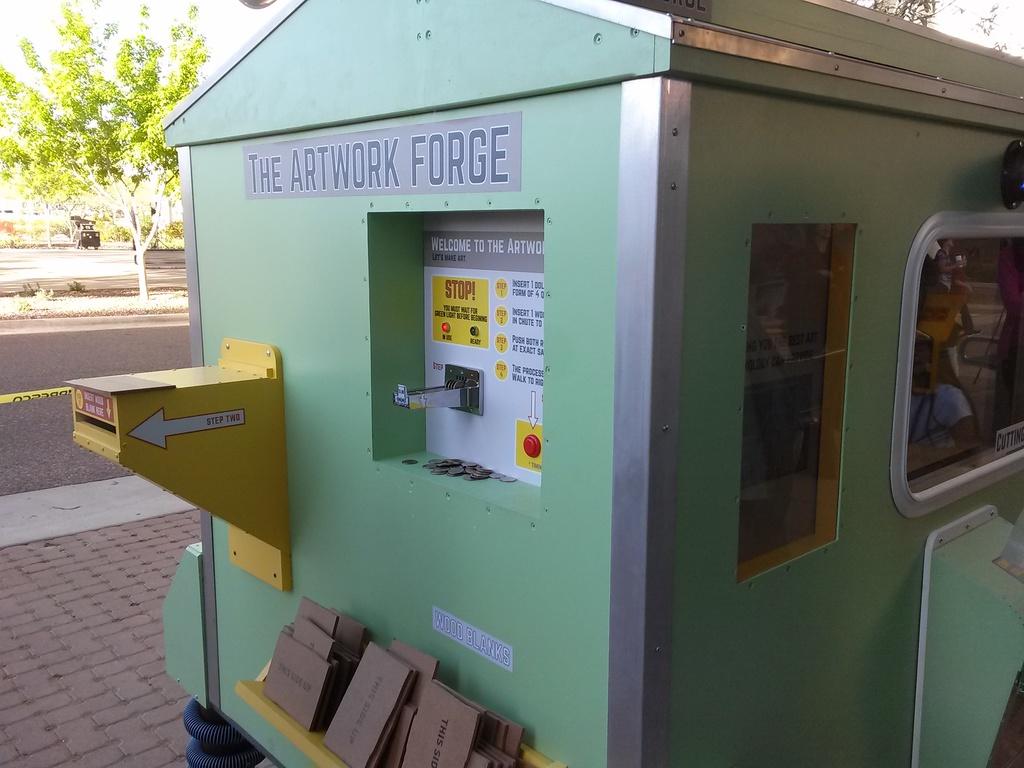What is the title of this building?
Give a very brief answer. The artwork forge. Some box are shown?
Your answer should be very brief. Yes. 